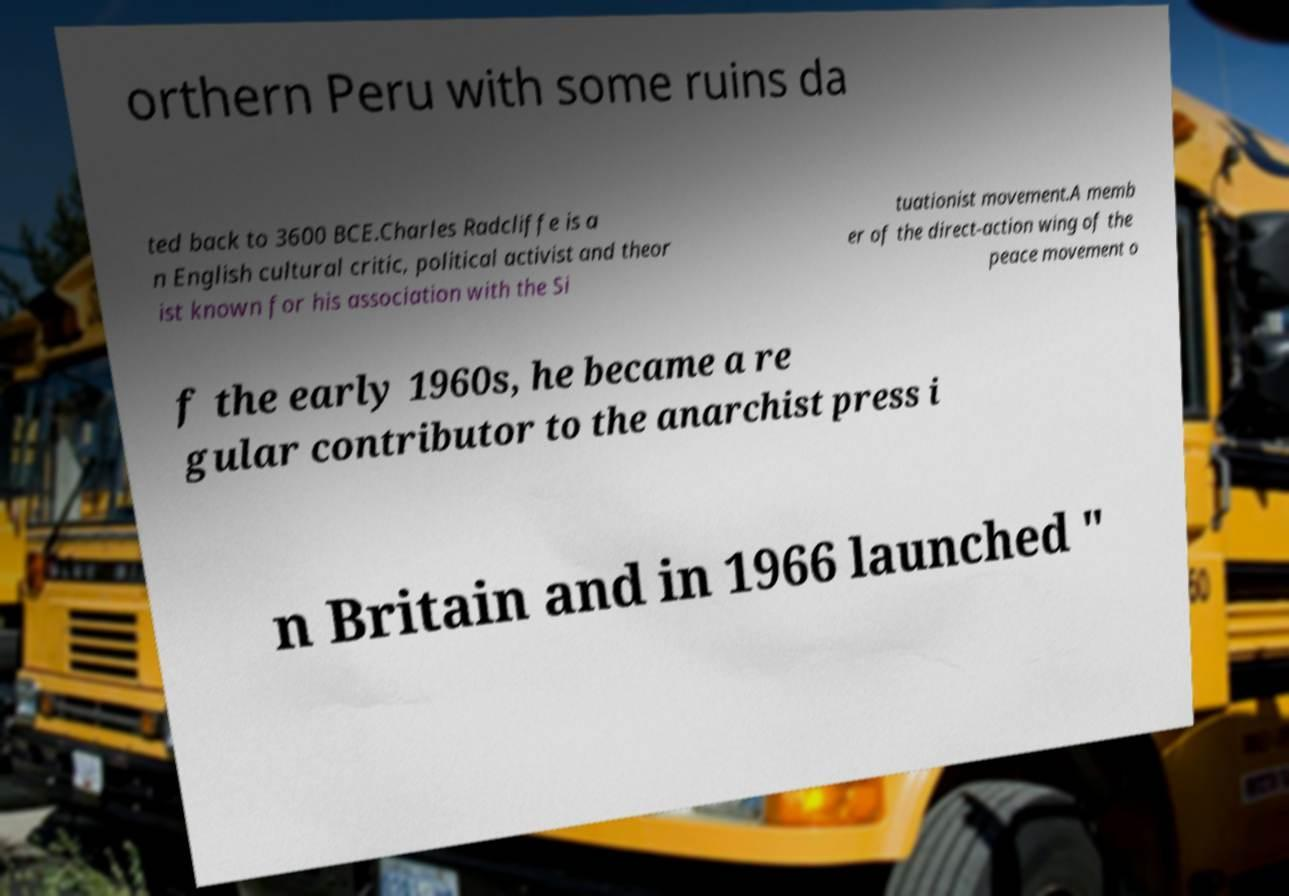For documentation purposes, I need the text within this image transcribed. Could you provide that? orthern Peru with some ruins da ted back to 3600 BCE.Charles Radcliffe is a n English cultural critic, political activist and theor ist known for his association with the Si tuationist movement.A memb er of the direct-action wing of the peace movement o f the early 1960s, he became a re gular contributor to the anarchist press i n Britain and in 1966 launched " 